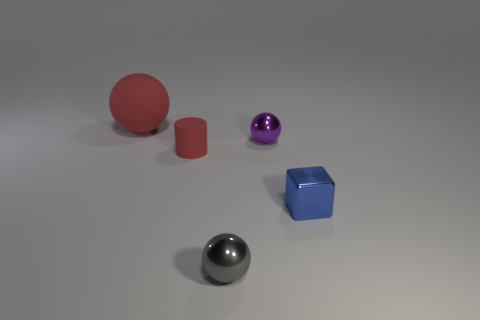Is there any other thing that has the same size as the red matte ball?
Ensure brevity in your answer.  No. How many balls are tiny gray shiny things or small red things?
Provide a short and direct response. 1. There is a metallic thing that is behind the metal cube; what is its shape?
Provide a short and direct response. Sphere. What color is the small metallic sphere in front of the tiny purple sphere to the right of the red object that is on the left side of the cylinder?
Your response must be concise. Gray. Does the large red ball have the same material as the cylinder?
Your response must be concise. Yes. What number of green things are cylinders or large rubber spheres?
Keep it short and to the point. 0. There is a matte ball; what number of red matte objects are in front of it?
Offer a terse response. 1. Are there more large red objects than tiny shiny balls?
Make the answer very short. No. There is a red object that is behind the tiny sphere that is to the right of the small gray metallic object; what shape is it?
Provide a succinct answer. Sphere. Do the big matte ball and the tiny rubber object have the same color?
Make the answer very short. Yes. 